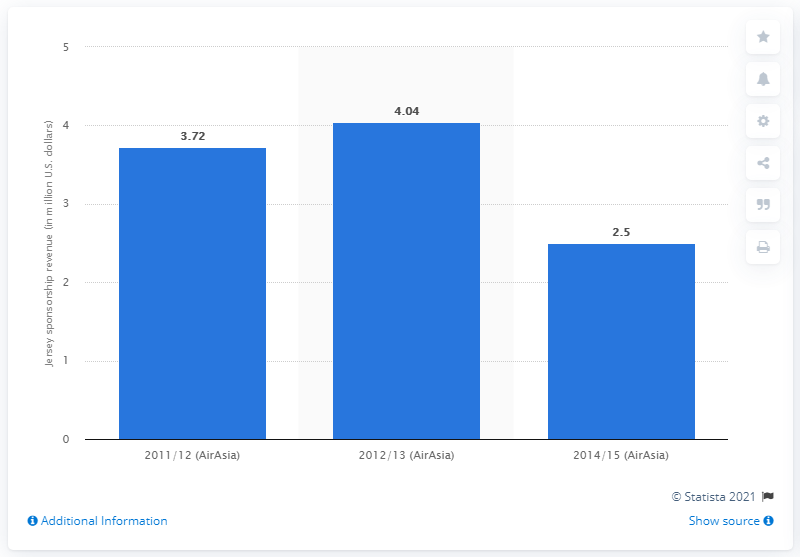Give some essential details in this illustration. Queens Park Rangers received 4,040,000 pounds from AirAsia during the 2012/13 season. 